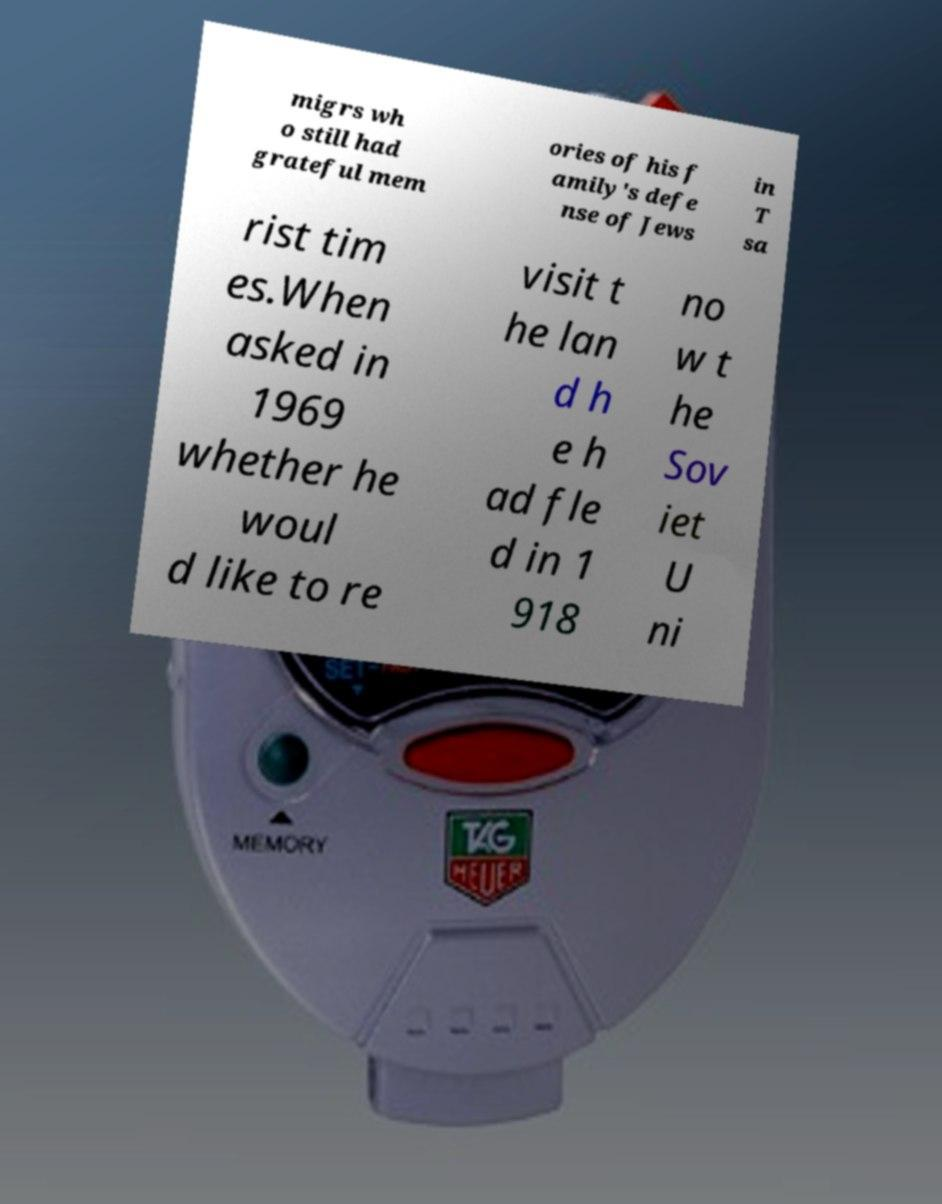Can you read and provide the text displayed in the image?This photo seems to have some interesting text. Can you extract and type it out for me? migrs wh o still had grateful mem ories of his f amily's defe nse of Jews in T sa rist tim es.When asked in 1969 whether he woul d like to re visit t he lan d h e h ad fle d in 1 918 no w t he Sov iet U ni 